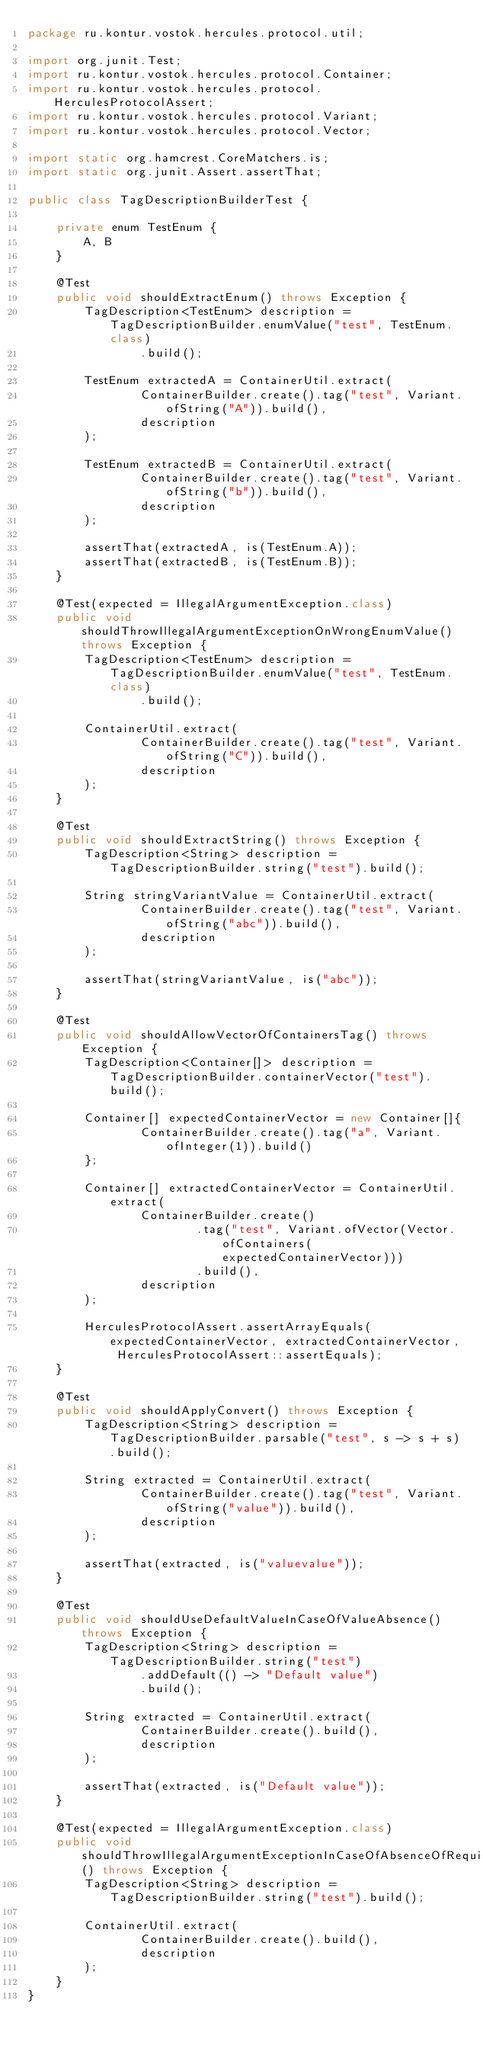<code> <loc_0><loc_0><loc_500><loc_500><_Java_>package ru.kontur.vostok.hercules.protocol.util;

import org.junit.Test;
import ru.kontur.vostok.hercules.protocol.Container;
import ru.kontur.vostok.hercules.protocol.HerculesProtocolAssert;
import ru.kontur.vostok.hercules.protocol.Variant;
import ru.kontur.vostok.hercules.protocol.Vector;

import static org.hamcrest.CoreMatchers.is;
import static org.junit.Assert.assertThat;

public class TagDescriptionBuilderTest {

    private enum TestEnum {
        A, B
    }

    @Test
    public void shouldExtractEnum() throws Exception {
        TagDescription<TestEnum> description = TagDescriptionBuilder.enumValue("test", TestEnum.class)
                .build();

        TestEnum extractedA = ContainerUtil.extract(
                ContainerBuilder.create().tag("test", Variant.ofString("A")).build(),
                description
        );

        TestEnum extractedB = ContainerUtil.extract(
                ContainerBuilder.create().tag("test", Variant.ofString("b")).build(),
                description
        );

        assertThat(extractedA, is(TestEnum.A));
        assertThat(extractedB, is(TestEnum.B));
    }

    @Test(expected = IllegalArgumentException.class)
    public void shouldThrowIllegalArgumentExceptionOnWrongEnumValue() throws Exception {
        TagDescription<TestEnum> description = TagDescriptionBuilder.enumValue("test", TestEnum.class)
                .build();

        ContainerUtil.extract(
                ContainerBuilder.create().tag("test", Variant.ofString("C")).build(),
                description
        );
    }

    @Test
    public void shouldExtractString() throws Exception {
        TagDescription<String> description = TagDescriptionBuilder.string("test").build();

        String stringVariantValue = ContainerUtil.extract(
                ContainerBuilder.create().tag("test", Variant.ofString("abc")).build(),
                description
        );

        assertThat(stringVariantValue, is("abc"));
    }

    @Test
    public void shouldAllowVectorOfContainersTag() throws Exception {
        TagDescription<Container[]> description = TagDescriptionBuilder.containerVector("test").build();

        Container[] expectedContainerVector = new Container[]{
                ContainerBuilder.create().tag("a", Variant.ofInteger(1)).build()
        };

        Container[] extractedContainerVector = ContainerUtil.extract(
                ContainerBuilder.create()
                        .tag("test", Variant.ofVector(Vector.ofContainers(expectedContainerVector)))
                        .build(),
                description
        );

        HerculesProtocolAssert.assertArrayEquals(expectedContainerVector, extractedContainerVector, HerculesProtocolAssert::assertEquals);
    }

    @Test
    public void shouldApplyConvert() throws Exception {
        TagDescription<String> description = TagDescriptionBuilder.parsable("test", s -> s + s).build();

        String extracted = ContainerUtil.extract(
                ContainerBuilder.create().tag("test", Variant.ofString("value")).build(),
                description
        );

        assertThat(extracted, is("valuevalue"));
    }

    @Test
    public void shouldUseDefaultValueInCaseOfValueAbsence() throws Exception {
        TagDescription<String> description = TagDescriptionBuilder.string("test")
                .addDefault(() -> "Default value")
                .build();

        String extracted = ContainerUtil.extract(
                ContainerBuilder.create().build(),
                description
        );

        assertThat(extracted, is("Default value"));
    }

    @Test(expected = IllegalArgumentException.class)
    public void shouldThrowIllegalArgumentExceptionInCaseOfAbsenceOfRequiredValue() throws Exception {
        TagDescription<String> description = TagDescriptionBuilder.string("test").build();

        ContainerUtil.extract(
                ContainerBuilder.create().build(),
                description
        );
    }
}
</code> 